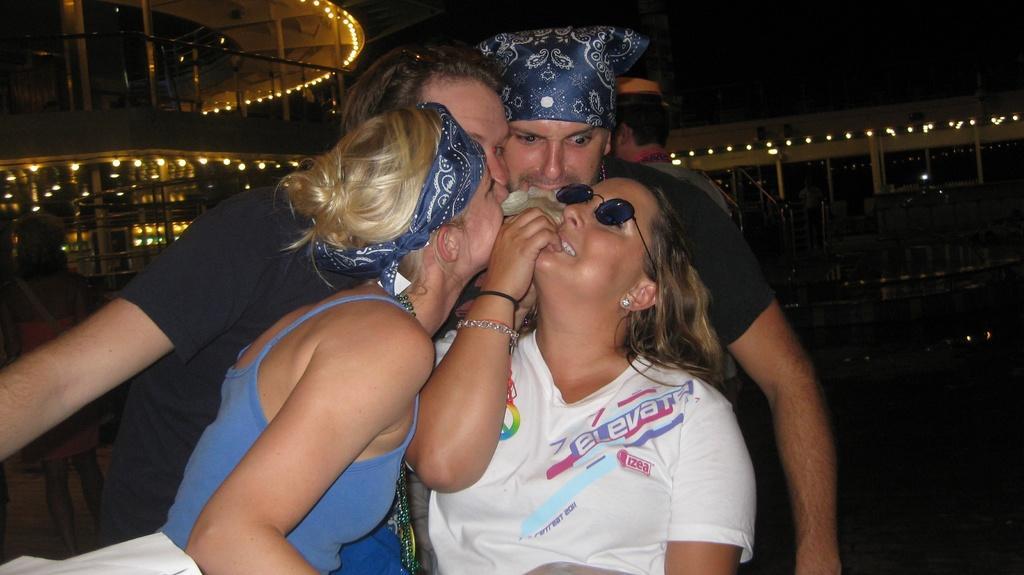In one or two sentences, can you explain what this image depicts? In the middle of the picture we can see four persons. In the background we can see a building, lights, staircase, and few persons. 